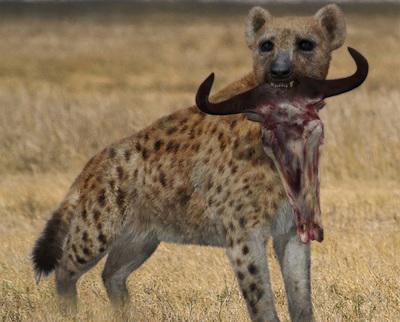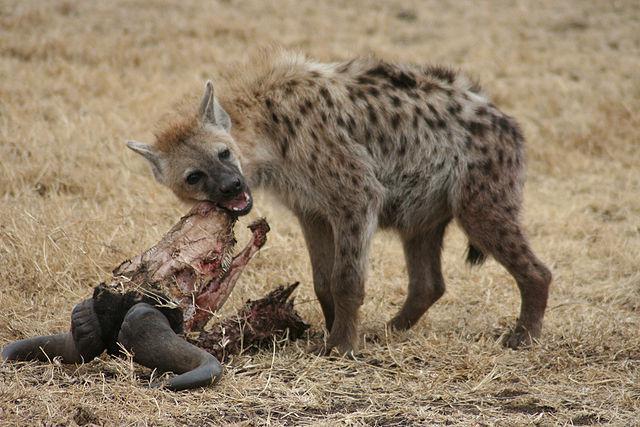The first image is the image on the left, the second image is the image on the right. Evaluate the accuracy of this statement regarding the images: "At least one image shows a single hyena with its mouth partly open showing teeth.". Is it true? Answer yes or no. Yes. 